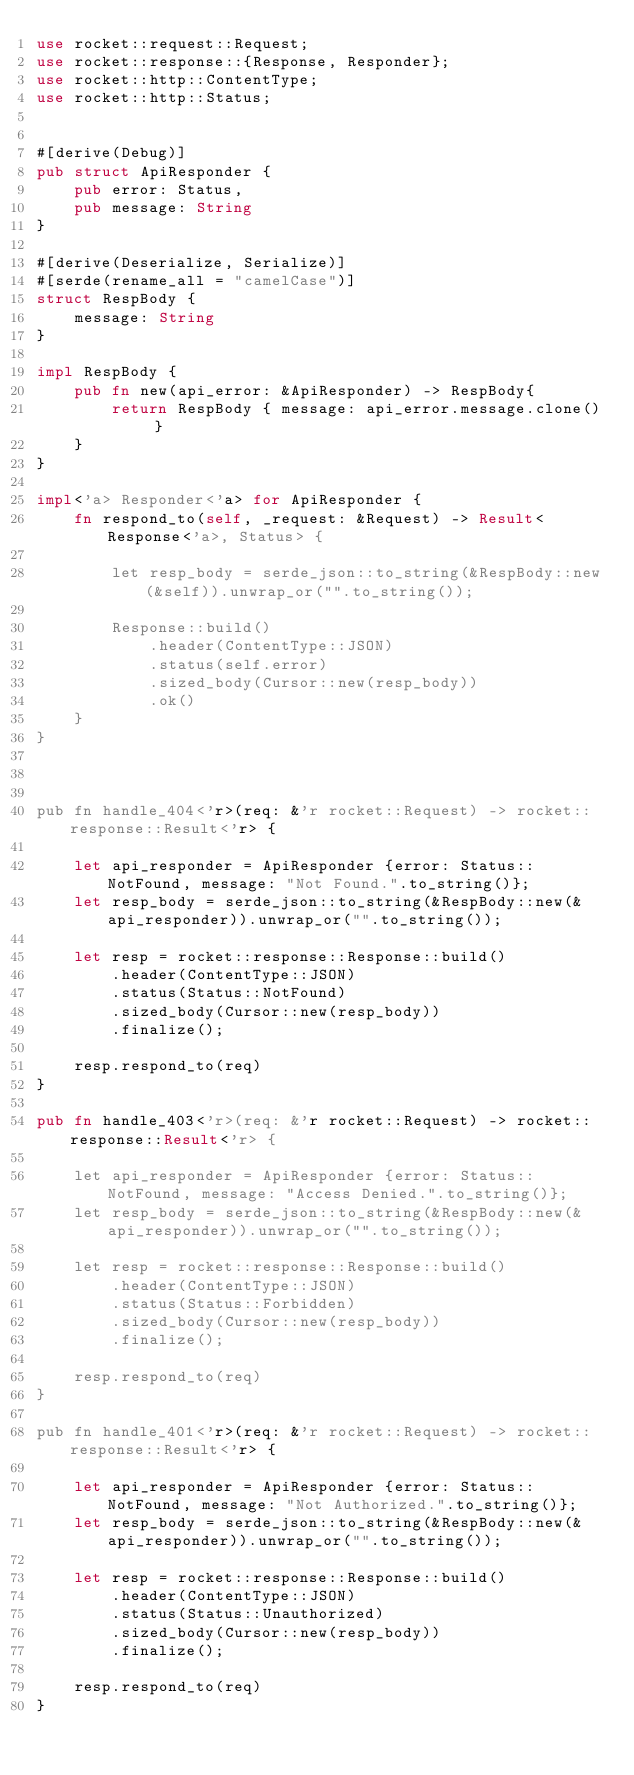<code> <loc_0><loc_0><loc_500><loc_500><_Rust_>use rocket::request::Request;
use rocket::response::{Response, Responder};
use rocket::http::ContentType;
use rocket::http::Status;


#[derive(Debug)]
pub struct ApiResponder {
    pub error: Status,
    pub message: String
}

#[derive(Deserialize, Serialize)]
#[serde(rename_all = "camelCase")]
struct RespBody {
    message: String
}

impl RespBody {
    pub fn new(api_error: &ApiResponder) -> RespBody{
        return RespBody { message: api_error.message.clone() }
    }
}

impl<'a> Responder<'a> for ApiResponder {
    fn respond_to(self, _request: &Request) -> Result<Response<'a>, Status> {

        let resp_body = serde_json::to_string(&RespBody::new(&self)).unwrap_or("".to_string());

        Response::build()
            .header(ContentType::JSON)
            .status(self.error)
            .sized_body(Cursor::new(resp_body))
            .ok()
    }
}



pub fn handle_404<'r>(req: &'r rocket::Request) -> rocket::response::Result<'r> {

    let api_responder = ApiResponder {error: Status::NotFound, message: "Not Found.".to_string()};
    let resp_body = serde_json::to_string(&RespBody::new(&api_responder)).unwrap_or("".to_string());

    let resp = rocket::response::Response::build()
        .header(ContentType::JSON)
        .status(Status::NotFound)
        .sized_body(Cursor::new(resp_body))
        .finalize();

    resp.respond_to(req)
}

pub fn handle_403<'r>(req: &'r rocket::Request) -> rocket::response::Result<'r> {

    let api_responder = ApiResponder {error: Status::NotFound, message: "Access Denied.".to_string()};
    let resp_body = serde_json::to_string(&RespBody::new(&api_responder)).unwrap_or("".to_string());

    let resp = rocket::response::Response::build()
        .header(ContentType::JSON)
        .status(Status::Forbidden)
        .sized_body(Cursor::new(resp_body))
        .finalize();

    resp.respond_to(req)
}

pub fn handle_401<'r>(req: &'r rocket::Request) -> rocket::response::Result<'r> {

    let api_responder = ApiResponder {error: Status::NotFound, message: "Not Authorized.".to_string()};
    let resp_body = serde_json::to_string(&RespBody::new(&api_responder)).unwrap_or("".to_string());

    let resp = rocket::response::Response::build()
        .header(ContentType::JSON)
        .status(Status::Unauthorized)
        .sized_body(Cursor::new(resp_body))
        .finalize();

    resp.respond_to(req)
}
</code> 